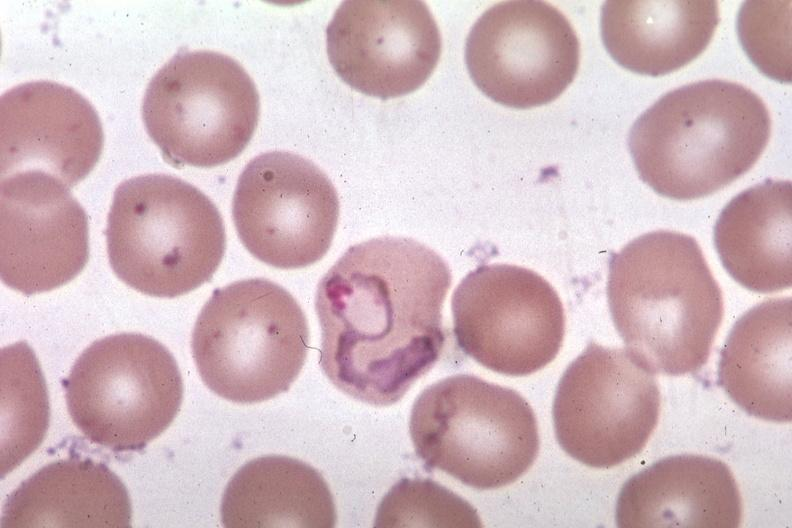s coronary atherosclerosis present?
Answer the question using a single word or phrase. No 